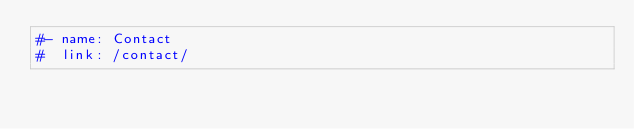<code> <loc_0><loc_0><loc_500><loc_500><_YAML_>#- name: Contact
#  link: /contact/
</code> 